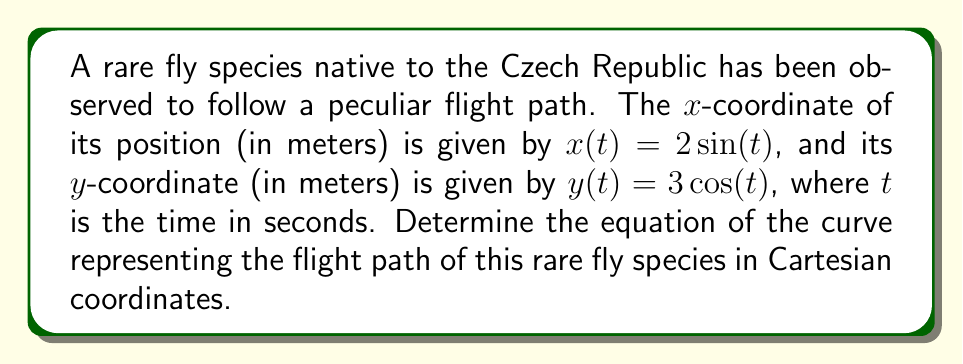Give your solution to this math problem. To find the equation of the curve in Cartesian coordinates, we need to eliminate the parameter $t$ from the given parametric equations.

Step 1: Square both sides of the equations for $x$ and $y$.
$x^2 = 4\sin^2(t)$
$y^2 = 9\cos^2(t)$

Step 2: Divide each equation by its respective coefficient squared.
$\frac{x^2}{4} = \sin^2(t)$
$\frac{y^2}{9} = \cos^2(t)$

Step 3: Add the two equations.
$\frac{x^2}{4} + \frac{y^2}{9} = \sin^2(t) + \cos^2(t)$

Step 4: Recall the trigonometric identity $\sin^2(t) + \cos^2(t) = 1$.
$\frac{x^2}{4} + \frac{y^2}{9} = 1$

This is the equation of an ellipse centered at the origin with semi-major axis 3 (along the y-axis) and semi-minor axis 2 (along the x-axis).
Answer: $\frac{x^2}{4} + \frac{y^2}{9} = 1$ 